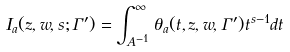Convert formula to latex. <formula><loc_0><loc_0><loc_500><loc_500>I _ { a } ( z , w , s ; \Gamma ^ { \prime } ) = \int _ { A ^ { - 1 } } ^ { \infty } \theta _ { a } ( t , z , w , \Gamma ^ { \prime } ) t ^ { s - 1 } d t</formula> 